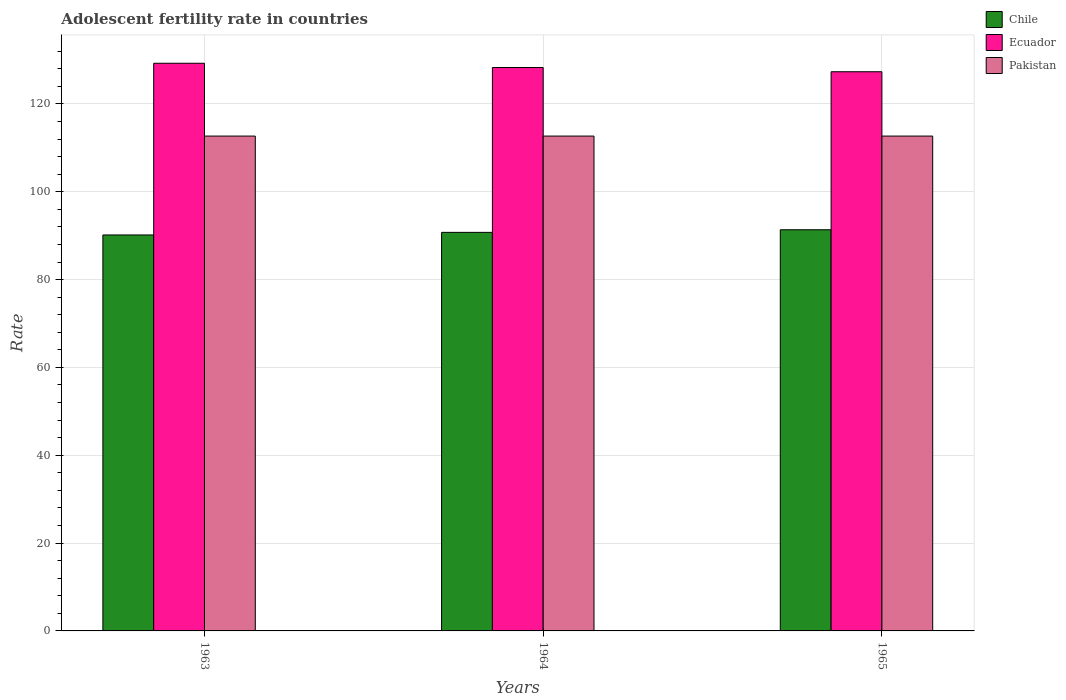How many different coloured bars are there?
Ensure brevity in your answer.  3. Are the number of bars on each tick of the X-axis equal?
Make the answer very short. Yes. How many bars are there on the 2nd tick from the right?
Keep it short and to the point. 3. What is the label of the 1st group of bars from the left?
Your answer should be very brief. 1963. What is the adolescent fertility rate in Chile in 1965?
Provide a succinct answer. 91.34. Across all years, what is the maximum adolescent fertility rate in Chile?
Keep it short and to the point. 91.34. Across all years, what is the minimum adolescent fertility rate in Chile?
Provide a succinct answer. 90.16. In which year was the adolescent fertility rate in Ecuador maximum?
Your response must be concise. 1963. In which year was the adolescent fertility rate in Ecuador minimum?
Provide a succinct answer. 1965. What is the total adolescent fertility rate in Ecuador in the graph?
Provide a succinct answer. 384.86. What is the difference between the adolescent fertility rate in Ecuador in 1963 and that in 1965?
Provide a short and direct response. 1.93. What is the difference between the adolescent fertility rate in Ecuador in 1965 and the adolescent fertility rate in Pakistan in 1964?
Provide a succinct answer. 14.65. What is the average adolescent fertility rate in Pakistan per year?
Give a very brief answer. 112.67. In the year 1965, what is the difference between the adolescent fertility rate in Ecuador and adolescent fertility rate in Pakistan?
Offer a terse response. 14.65. In how many years, is the adolescent fertility rate in Chile greater than 112?
Give a very brief answer. 0. Is the difference between the adolescent fertility rate in Ecuador in 1964 and 1965 greater than the difference between the adolescent fertility rate in Pakistan in 1964 and 1965?
Ensure brevity in your answer.  Yes. What is the difference between the highest and the second highest adolescent fertility rate in Ecuador?
Provide a succinct answer. 0.97. What is the difference between the highest and the lowest adolescent fertility rate in Chile?
Your answer should be very brief. 1.18. In how many years, is the adolescent fertility rate in Ecuador greater than the average adolescent fertility rate in Ecuador taken over all years?
Give a very brief answer. 1. Is the sum of the adolescent fertility rate in Pakistan in 1964 and 1965 greater than the maximum adolescent fertility rate in Chile across all years?
Offer a very short reply. Yes. What does the 2nd bar from the left in 1965 represents?
Provide a short and direct response. Ecuador. What does the 1st bar from the right in 1964 represents?
Your response must be concise. Pakistan. What is the difference between two consecutive major ticks on the Y-axis?
Make the answer very short. 20. Where does the legend appear in the graph?
Keep it short and to the point. Top right. How are the legend labels stacked?
Your answer should be compact. Vertical. What is the title of the graph?
Offer a very short reply. Adolescent fertility rate in countries. Does "Tunisia" appear as one of the legend labels in the graph?
Give a very brief answer. No. What is the label or title of the Y-axis?
Your answer should be very brief. Rate. What is the Rate of Chile in 1963?
Your response must be concise. 90.16. What is the Rate of Ecuador in 1963?
Your answer should be very brief. 129.25. What is the Rate of Pakistan in 1963?
Ensure brevity in your answer.  112.67. What is the Rate in Chile in 1964?
Your response must be concise. 90.75. What is the Rate of Ecuador in 1964?
Provide a succinct answer. 128.29. What is the Rate in Pakistan in 1964?
Provide a succinct answer. 112.67. What is the Rate in Chile in 1965?
Offer a terse response. 91.34. What is the Rate in Ecuador in 1965?
Your answer should be very brief. 127.32. What is the Rate in Pakistan in 1965?
Keep it short and to the point. 112.67. Across all years, what is the maximum Rate of Chile?
Provide a short and direct response. 91.34. Across all years, what is the maximum Rate in Ecuador?
Offer a very short reply. 129.25. Across all years, what is the maximum Rate of Pakistan?
Provide a short and direct response. 112.67. Across all years, what is the minimum Rate of Chile?
Your response must be concise. 90.16. Across all years, what is the minimum Rate of Ecuador?
Provide a succinct answer. 127.32. Across all years, what is the minimum Rate in Pakistan?
Provide a short and direct response. 112.67. What is the total Rate in Chile in the graph?
Your answer should be compact. 272.25. What is the total Rate in Ecuador in the graph?
Your answer should be very brief. 384.86. What is the total Rate in Pakistan in the graph?
Provide a short and direct response. 338.02. What is the difference between the Rate of Chile in 1963 and that in 1964?
Offer a terse response. -0.59. What is the difference between the Rate of Ecuador in 1963 and that in 1964?
Give a very brief answer. 0.97. What is the difference between the Rate in Chile in 1963 and that in 1965?
Your answer should be compact. -1.18. What is the difference between the Rate in Ecuador in 1963 and that in 1965?
Keep it short and to the point. 1.93. What is the difference between the Rate in Pakistan in 1963 and that in 1965?
Your answer should be very brief. 0. What is the difference between the Rate in Chile in 1964 and that in 1965?
Make the answer very short. -0.59. What is the difference between the Rate of Ecuador in 1964 and that in 1965?
Give a very brief answer. 0.97. What is the difference between the Rate of Pakistan in 1964 and that in 1965?
Make the answer very short. 0. What is the difference between the Rate of Chile in 1963 and the Rate of Ecuador in 1964?
Your answer should be very brief. -38.13. What is the difference between the Rate in Chile in 1963 and the Rate in Pakistan in 1964?
Offer a terse response. -22.52. What is the difference between the Rate of Ecuador in 1963 and the Rate of Pakistan in 1964?
Keep it short and to the point. 16.58. What is the difference between the Rate in Chile in 1963 and the Rate in Ecuador in 1965?
Your answer should be compact. -37.16. What is the difference between the Rate in Chile in 1963 and the Rate in Pakistan in 1965?
Make the answer very short. -22.52. What is the difference between the Rate of Ecuador in 1963 and the Rate of Pakistan in 1965?
Offer a terse response. 16.58. What is the difference between the Rate of Chile in 1964 and the Rate of Ecuador in 1965?
Keep it short and to the point. -36.57. What is the difference between the Rate in Chile in 1964 and the Rate in Pakistan in 1965?
Offer a terse response. -21.93. What is the difference between the Rate in Ecuador in 1964 and the Rate in Pakistan in 1965?
Your answer should be compact. 15.61. What is the average Rate in Chile per year?
Your answer should be compact. 90.75. What is the average Rate of Ecuador per year?
Ensure brevity in your answer.  128.29. What is the average Rate in Pakistan per year?
Provide a succinct answer. 112.67. In the year 1963, what is the difference between the Rate in Chile and Rate in Ecuador?
Provide a short and direct response. -39.1. In the year 1963, what is the difference between the Rate in Chile and Rate in Pakistan?
Offer a terse response. -22.52. In the year 1963, what is the difference between the Rate of Ecuador and Rate of Pakistan?
Give a very brief answer. 16.58. In the year 1964, what is the difference between the Rate in Chile and Rate in Ecuador?
Your answer should be very brief. -37.54. In the year 1964, what is the difference between the Rate in Chile and Rate in Pakistan?
Keep it short and to the point. -21.93. In the year 1964, what is the difference between the Rate of Ecuador and Rate of Pakistan?
Offer a very short reply. 15.61. In the year 1965, what is the difference between the Rate of Chile and Rate of Ecuador?
Your answer should be compact. -35.98. In the year 1965, what is the difference between the Rate in Chile and Rate in Pakistan?
Your answer should be very brief. -21.33. In the year 1965, what is the difference between the Rate of Ecuador and Rate of Pakistan?
Your answer should be compact. 14.65. What is the ratio of the Rate of Ecuador in 1963 to that in 1964?
Give a very brief answer. 1.01. What is the ratio of the Rate in Chile in 1963 to that in 1965?
Make the answer very short. 0.99. What is the ratio of the Rate in Ecuador in 1963 to that in 1965?
Offer a very short reply. 1.02. What is the ratio of the Rate in Pakistan in 1963 to that in 1965?
Your answer should be compact. 1. What is the ratio of the Rate of Ecuador in 1964 to that in 1965?
Your response must be concise. 1.01. What is the ratio of the Rate of Pakistan in 1964 to that in 1965?
Provide a succinct answer. 1. What is the difference between the highest and the second highest Rate in Chile?
Your response must be concise. 0.59. What is the difference between the highest and the second highest Rate in Ecuador?
Your answer should be very brief. 0.97. What is the difference between the highest and the lowest Rate in Chile?
Offer a very short reply. 1.18. What is the difference between the highest and the lowest Rate of Ecuador?
Provide a short and direct response. 1.93. What is the difference between the highest and the lowest Rate of Pakistan?
Ensure brevity in your answer.  0. 